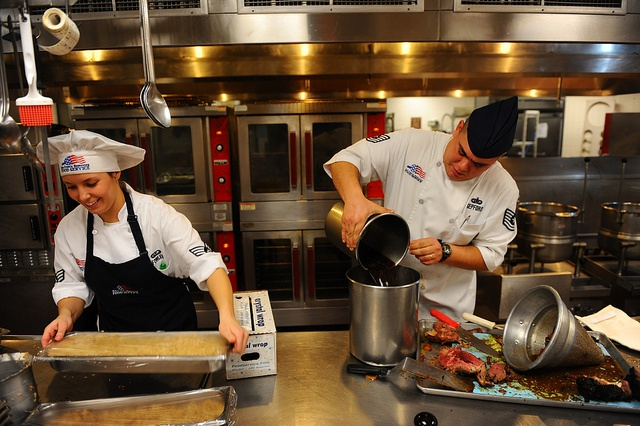Describe the objects in this image and their specific colors. I can see people in black, lightgray, darkgray, and tan tones, people in black and tan tones, oven in black and gray tones, oven in black, maroon, and olive tones, and oven in black, maroon, and gray tones in this image. 